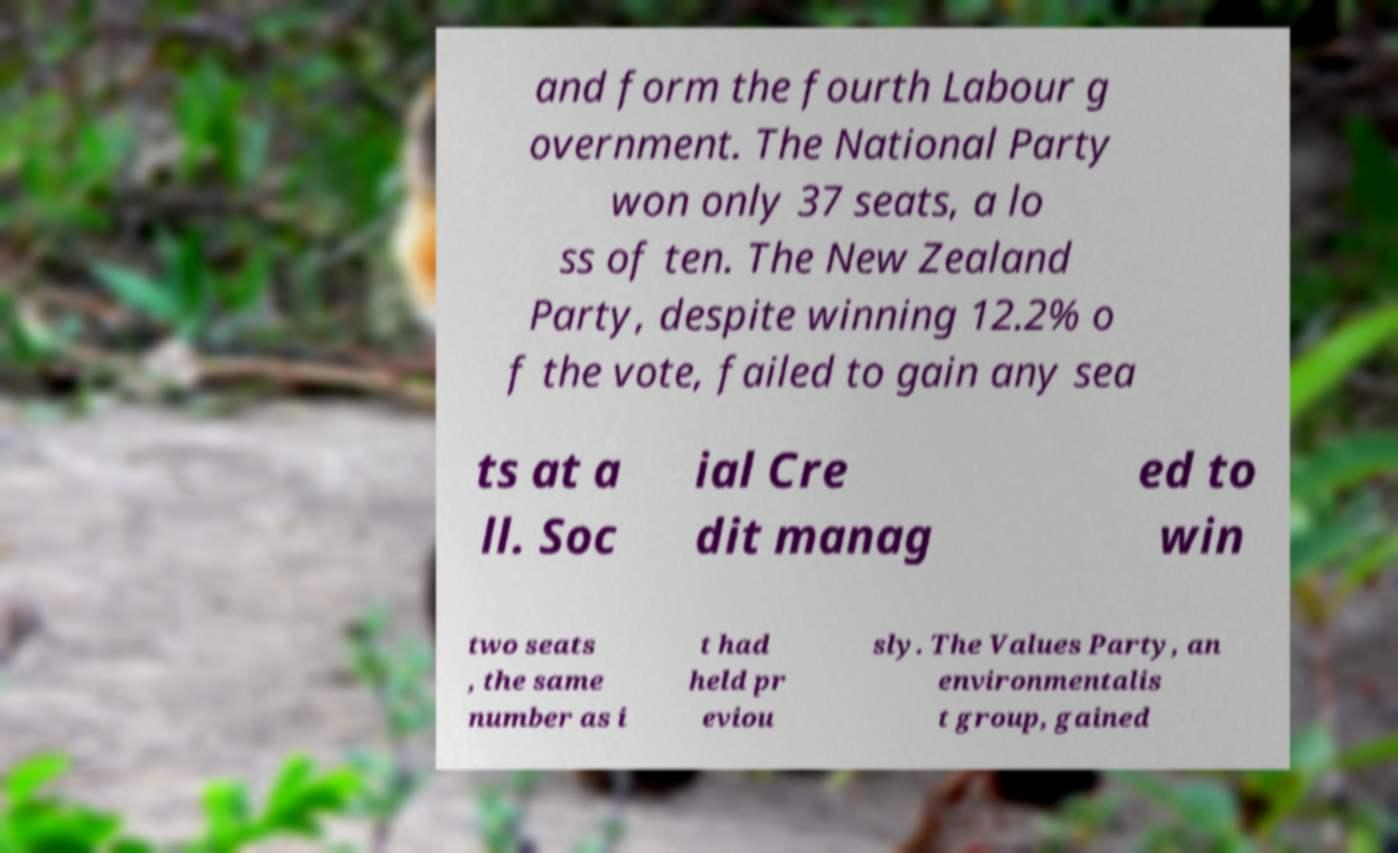Please identify and transcribe the text found in this image. and form the fourth Labour g overnment. The National Party won only 37 seats, a lo ss of ten. The New Zealand Party, despite winning 12.2% o f the vote, failed to gain any sea ts at a ll. Soc ial Cre dit manag ed to win two seats , the same number as i t had held pr eviou sly. The Values Party, an environmentalis t group, gained 